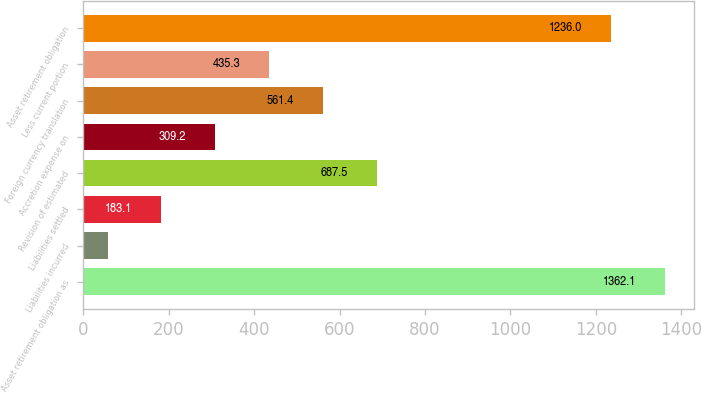Convert chart to OTSL. <chart><loc_0><loc_0><loc_500><loc_500><bar_chart><fcel>Asset retirement obligation as<fcel>Liabilities incurred<fcel>Liabilities settled<fcel>Revision of estimated<fcel>Accretion expense on<fcel>Foreign currency translation<fcel>Less current portion<fcel>Asset retirement obligation<nl><fcel>1362.1<fcel>57<fcel>183.1<fcel>687.5<fcel>309.2<fcel>561.4<fcel>435.3<fcel>1236<nl></chart> 